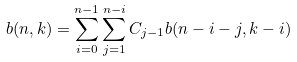<formula> <loc_0><loc_0><loc_500><loc_500>b ( n , k ) = \sum _ { i = 0 } ^ { n - 1 } \sum _ { j = 1 } ^ { n - i } C _ { j - 1 } b ( n - i - j , k - i )</formula> 